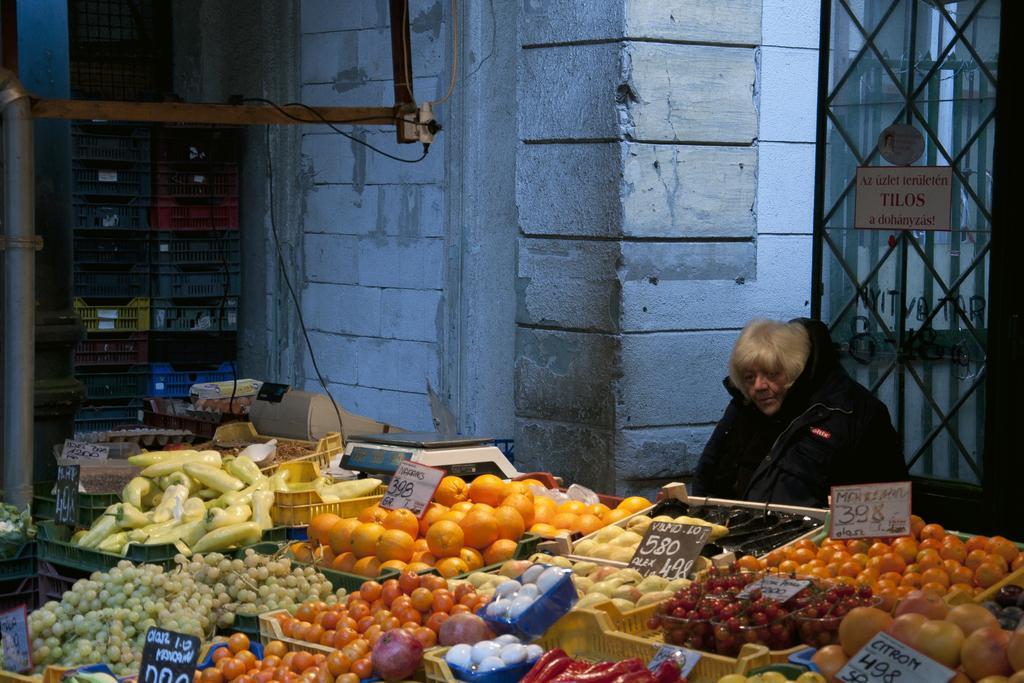Could you give a brief overview of what you see in this image? In this picture I can see a building and I can see fruits and few vegetables in the baskets and I can see boards with some text and I can see a weighing machine and a billing machine on the side and I can see a human seated and few baskets on the left side and I can see a metal grill with a board and I can see text on it. 